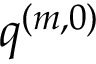<formula> <loc_0><loc_0><loc_500><loc_500>\boldsymbol q ^ { ( m , 0 ) }</formula> 